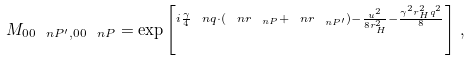<formula> <loc_0><loc_0><loc_500><loc_500>M _ { 0 0 \ n P ^ { \prime } , 0 0 \ n P } = \exp \left [ ^ { i \frac { \gamma } { 4 } \ n q \cdot ( \ n r _ { \ n P } + \ n r _ { \ n P ^ { \prime } } ) - \frac { u ^ { 2 } } { 8 r _ { H } ^ { 2 } } - \frac { \gamma ^ { 2 } r _ { H } ^ { 2 } q ^ { 2 } } { 8 } } \right ] \, ,</formula> 